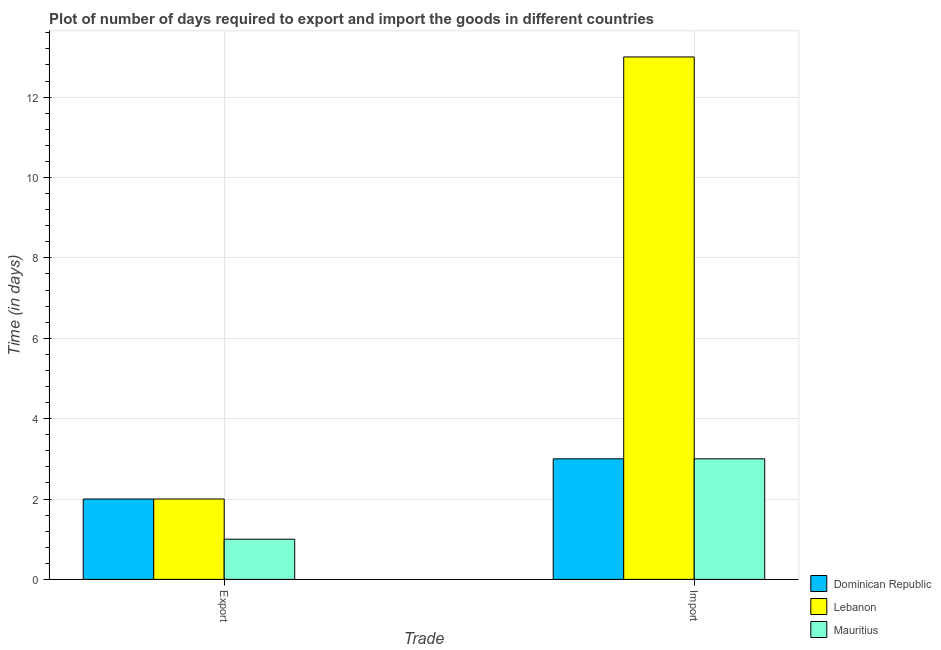How many different coloured bars are there?
Ensure brevity in your answer.  3. Are the number of bars per tick equal to the number of legend labels?
Give a very brief answer. Yes. Are the number of bars on each tick of the X-axis equal?
Offer a very short reply. Yes. How many bars are there on the 2nd tick from the left?
Give a very brief answer. 3. What is the label of the 2nd group of bars from the left?
Your answer should be very brief. Import. What is the time required to import in Lebanon?
Keep it short and to the point. 13. Across all countries, what is the maximum time required to export?
Your response must be concise. 2. Across all countries, what is the minimum time required to import?
Your answer should be compact. 3. In which country was the time required to import maximum?
Your response must be concise. Lebanon. In which country was the time required to export minimum?
Make the answer very short. Mauritius. What is the total time required to import in the graph?
Offer a terse response. 19. What is the difference between the time required to export in Lebanon and that in Mauritius?
Your answer should be compact. 1. What is the difference between the time required to import in Lebanon and the time required to export in Dominican Republic?
Provide a short and direct response. 11. What is the average time required to import per country?
Provide a short and direct response. 6.33. What is the difference between the time required to import and time required to export in Lebanon?
Make the answer very short. 11. In how many countries, is the time required to export greater than 11.6 days?
Provide a short and direct response. 0. What does the 3rd bar from the left in Import represents?
Provide a succinct answer. Mauritius. What does the 2nd bar from the right in Export represents?
Offer a very short reply. Lebanon. How many bars are there?
Ensure brevity in your answer.  6. How many countries are there in the graph?
Offer a very short reply. 3. Are the values on the major ticks of Y-axis written in scientific E-notation?
Offer a very short reply. No. Does the graph contain grids?
Offer a very short reply. Yes. How many legend labels are there?
Give a very brief answer. 3. How are the legend labels stacked?
Give a very brief answer. Vertical. What is the title of the graph?
Provide a short and direct response. Plot of number of days required to export and import the goods in different countries. What is the label or title of the X-axis?
Offer a terse response. Trade. What is the label or title of the Y-axis?
Provide a succinct answer. Time (in days). What is the Time (in days) in Dominican Republic in Export?
Keep it short and to the point. 2. What is the Time (in days) in Lebanon in Export?
Provide a succinct answer. 2. What is the Time (in days) in Lebanon in Import?
Keep it short and to the point. 13. What is the Time (in days) of Mauritius in Import?
Make the answer very short. 3. Across all Trade, what is the maximum Time (in days) of Lebanon?
Provide a short and direct response. 13. Across all Trade, what is the maximum Time (in days) in Mauritius?
Make the answer very short. 3. Across all Trade, what is the minimum Time (in days) in Dominican Republic?
Your answer should be compact. 2. What is the total Time (in days) of Dominican Republic in the graph?
Offer a very short reply. 5. What is the total Time (in days) of Lebanon in the graph?
Your answer should be very brief. 15. What is the difference between the Time (in days) in Lebanon in Export and that in Import?
Your answer should be very brief. -11. What is the difference between the Time (in days) in Mauritius in Export and that in Import?
Your answer should be very brief. -2. What is the difference between the Time (in days) in Lebanon in Export and the Time (in days) in Mauritius in Import?
Give a very brief answer. -1. What is the average Time (in days) of Dominican Republic per Trade?
Your response must be concise. 2.5. What is the average Time (in days) of Lebanon per Trade?
Offer a terse response. 7.5. What is the average Time (in days) of Mauritius per Trade?
Your answer should be compact. 2. What is the difference between the Time (in days) in Lebanon and Time (in days) in Mauritius in Export?
Provide a succinct answer. 1. What is the difference between the Time (in days) of Lebanon and Time (in days) of Mauritius in Import?
Your answer should be very brief. 10. What is the ratio of the Time (in days) of Lebanon in Export to that in Import?
Provide a succinct answer. 0.15. What is the ratio of the Time (in days) of Mauritius in Export to that in Import?
Ensure brevity in your answer.  0.33. What is the difference between the highest and the second highest Time (in days) of Dominican Republic?
Give a very brief answer. 1. What is the difference between the highest and the second highest Time (in days) of Mauritius?
Your answer should be compact. 2. What is the difference between the highest and the lowest Time (in days) in Mauritius?
Provide a succinct answer. 2. 